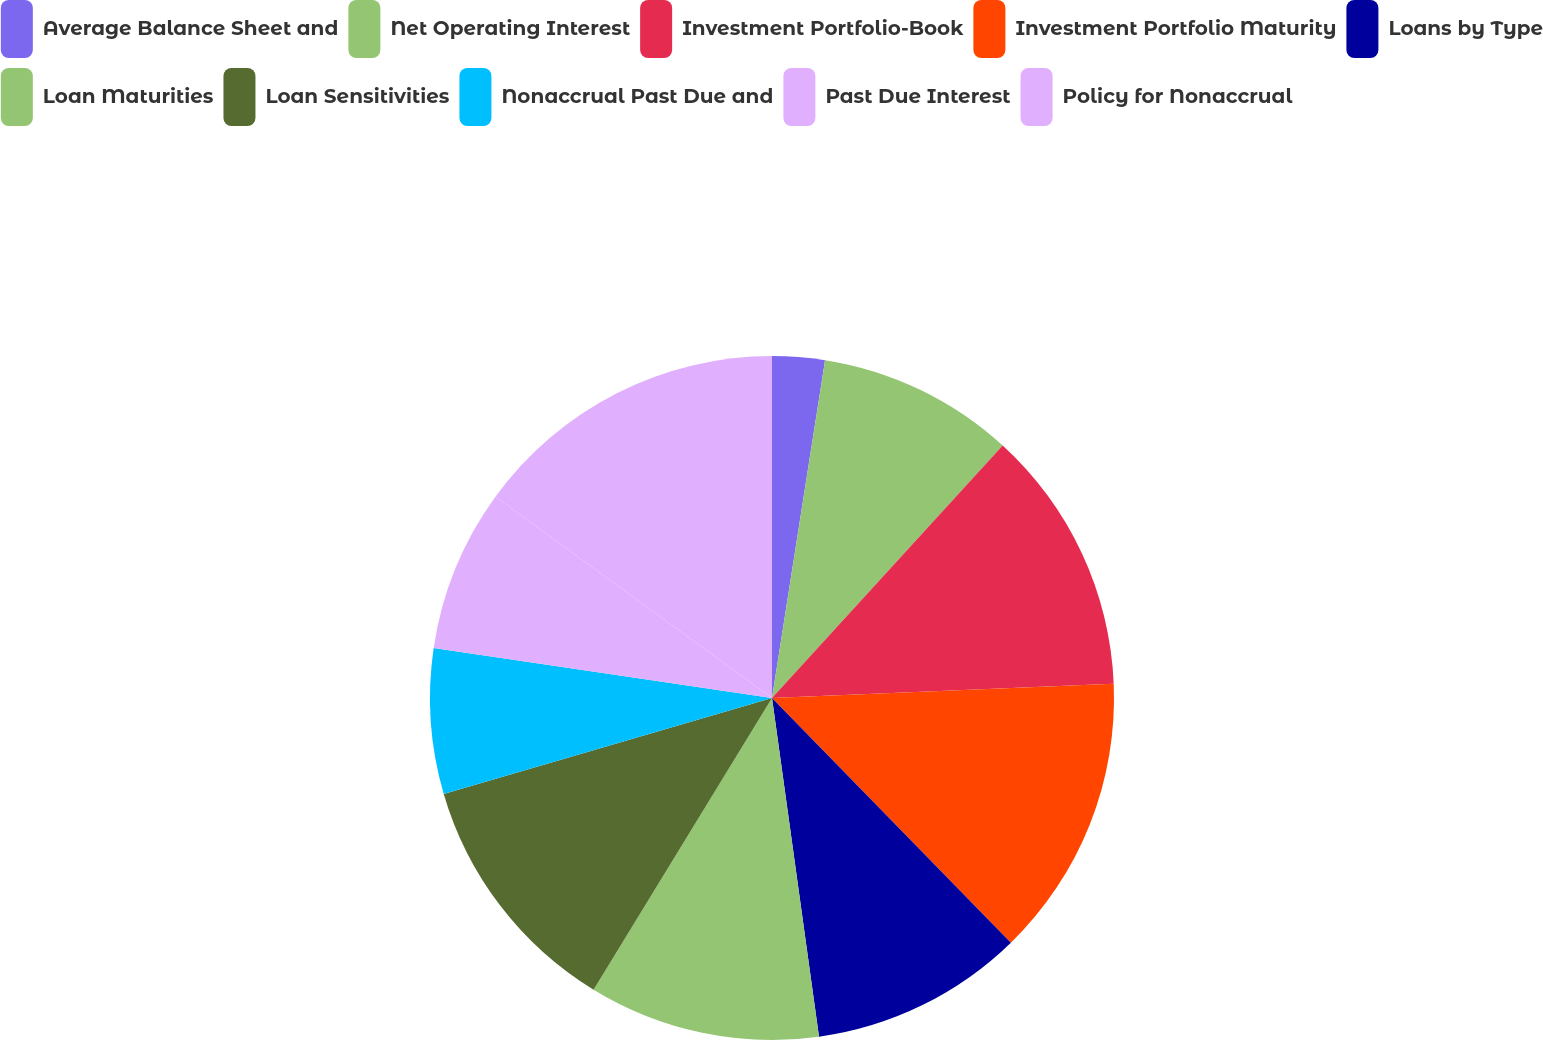Convert chart to OTSL. <chart><loc_0><loc_0><loc_500><loc_500><pie_chart><fcel>Average Balance Sheet and<fcel>Net Operating Interest<fcel>Investment Portfolio-Book<fcel>Investment Portfolio Maturity<fcel>Loans by Type<fcel>Loan Maturities<fcel>Loan Sensitivities<fcel>Nonaccrual Past Due and<fcel>Past Due Interest<fcel>Policy for Nonaccrual<nl><fcel>2.48%<fcel>9.3%<fcel>12.55%<fcel>13.36%<fcel>10.11%<fcel>10.93%<fcel>11.74%<fcel>6.86%<fcel>7.67%<fcel>14.99%<nl></chart> 